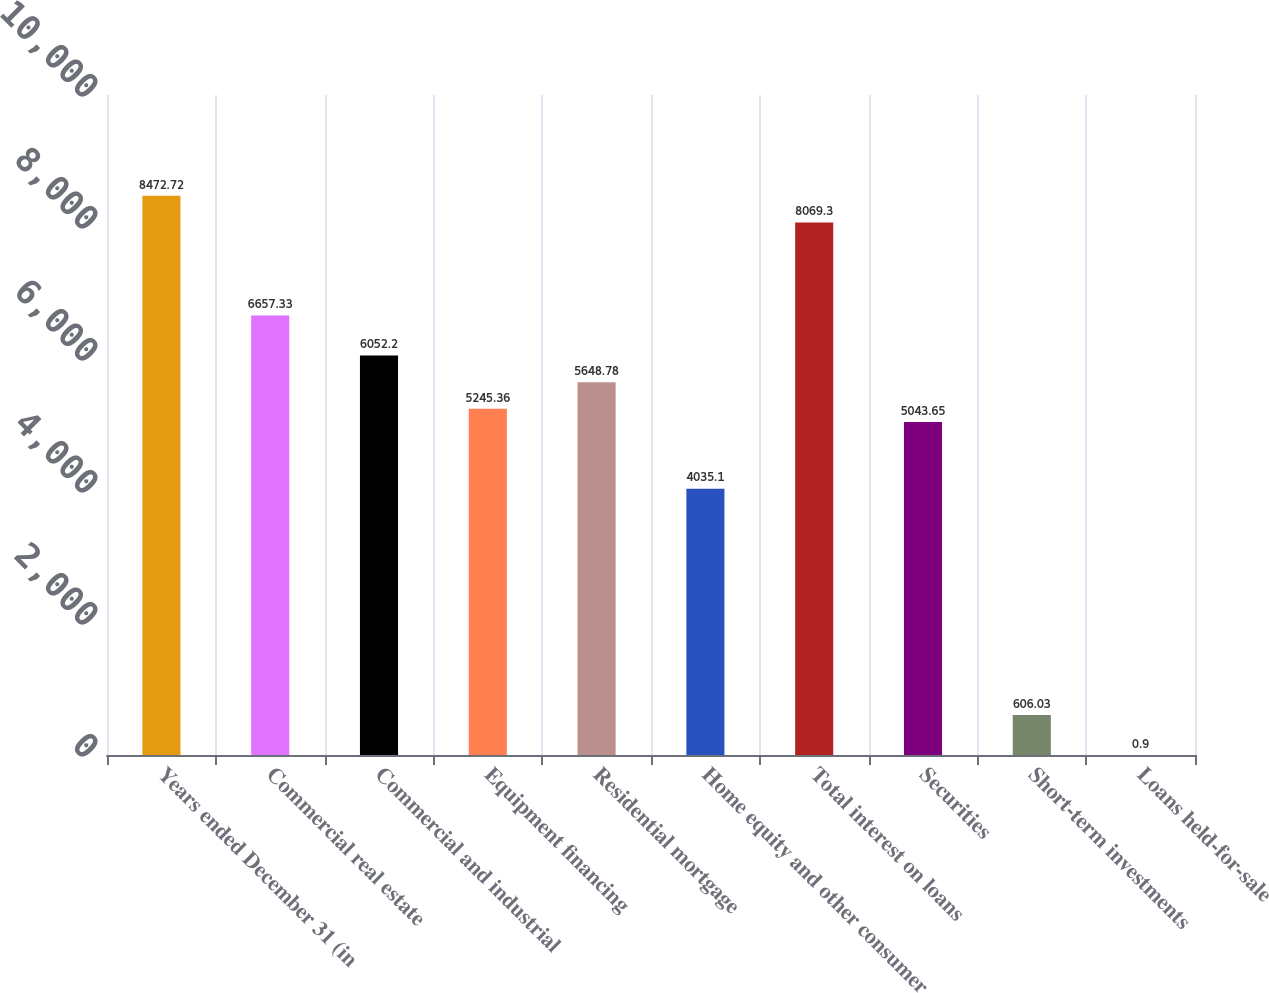<chart> <loc_0><loc_0><loc_500><loc_500><bar_chart><fcel>Years ended December 31 (in<fcel>Commercial real estate<fcel>Commercial and industrial<fcel>Equipment financing<fcel>Residential mortgage<fcel>Home equity and other consumer<fcel>Total interest on loans<fcel>Securities<fcel>Short-term investments<fcel>Loans held-for-sale<nl><fcel>8472.72<fcel>6657.33<fcel>6052.2<fcel>5245.36<fcel>5648.78<fcel>4035.1<fcel>8069.3<fcel>5043.65<fcel>606.03<fcel>0.9<nl></chart> 